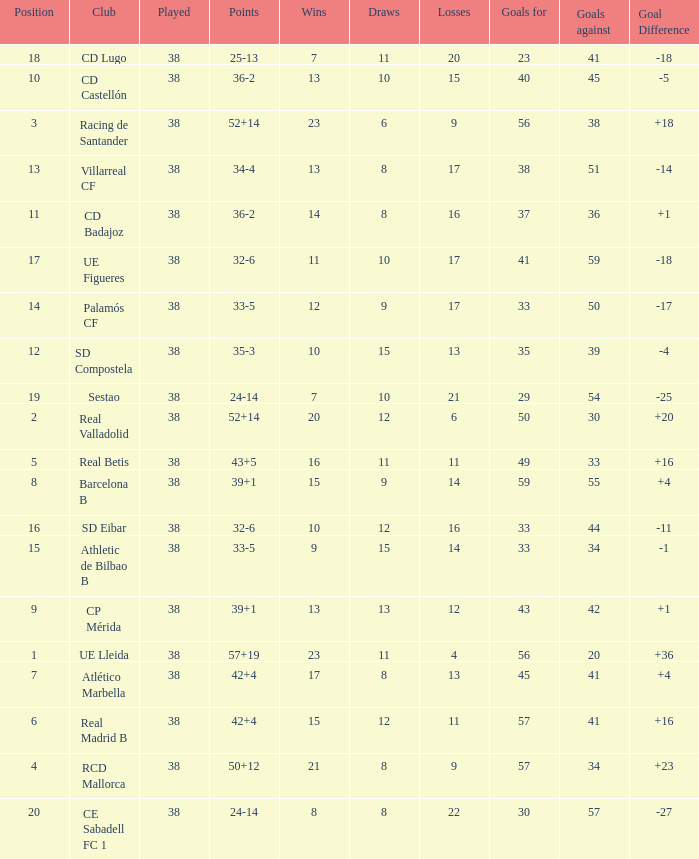What is the average goal difference with 51 goals scored against and less than 17 losses? None. 